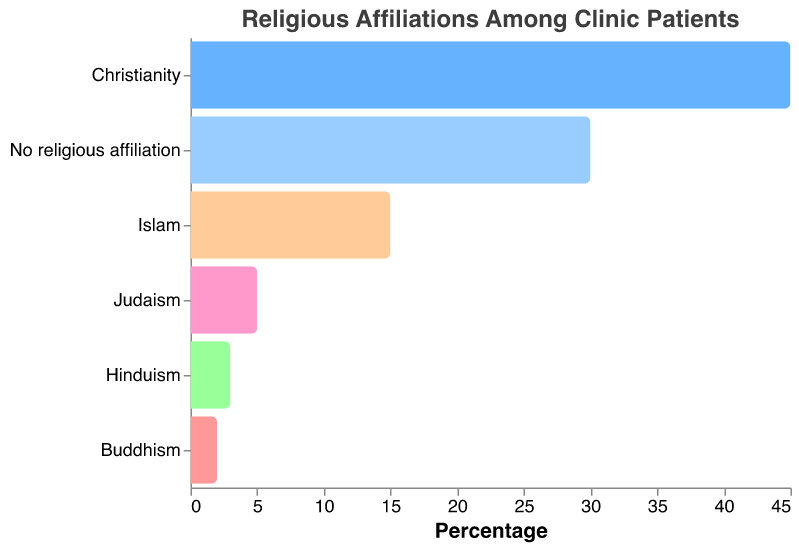How many different religious affiliations are represented among the clinic patients? Count the unique categories under "Religion" in the chart.
Answer: 6 Which religious affiliation has the highest percentage of patients? Look for the bar with the longest length representing the highest percentage.
Answer: Christianity What is the total percentage of patients who have either no religious affiliation or identify as Christians? Sum the percentages of "No religious affiliation" (30%) and "Christianity" (45%).
Answer: 75% How does the percentage of Islamic patients compare to that of Jewish patients? Compare the percentage values for "Islam" (15%) and "Judaism" (5%).
Answer: Islam has a higher percentage What is the cumulative percentage of patients who follow a religion other than Christianity? Sum the percentages of "No religious affiliation" (30%), "Islam" (15%), "Judaism" (5%), "Hinduism" (3%), and "Buddhism" (2%).
Answer: 55% Which religious affiliations comprise less than 10% of the patient population individually? Identify the religions where the percentage value is less than 10%.
Answer: Judaism, Hinduism, Buddhism For religions where the percentage is less than 10%, what is the combined percentage of patients? Sum the percentages of "Judaism" (5%), "Hinduism" (3%), and "Buddhism" (2%).
Answer: 10% If you were to group Hinduism and Buddhism together, how would their combined percentage compare to the percentage of Judaism? Sum the percentages for "Hinduism" (3%) and "Buddhism" (2%), then compare to "Judaism" (5%).
Answer: They are equal What is the average percentage of patients for all represented religious affiliations? Sum all percentage values and then divide by the number of affiliations: (45% + 30% + 15% + 5% + 3% + 2%) / 6.
Answer: 16.67% If patients with no religious affiliation are excluded, what is the average percentage of patients for the remaining religious affiliations? Exclude the "No religious affiliation" percentage, then sum the remaining percentages and divide by the number of affiliations: (45% + 15% + 5% + 3% + 2%) / 5.
Answer: 14% 